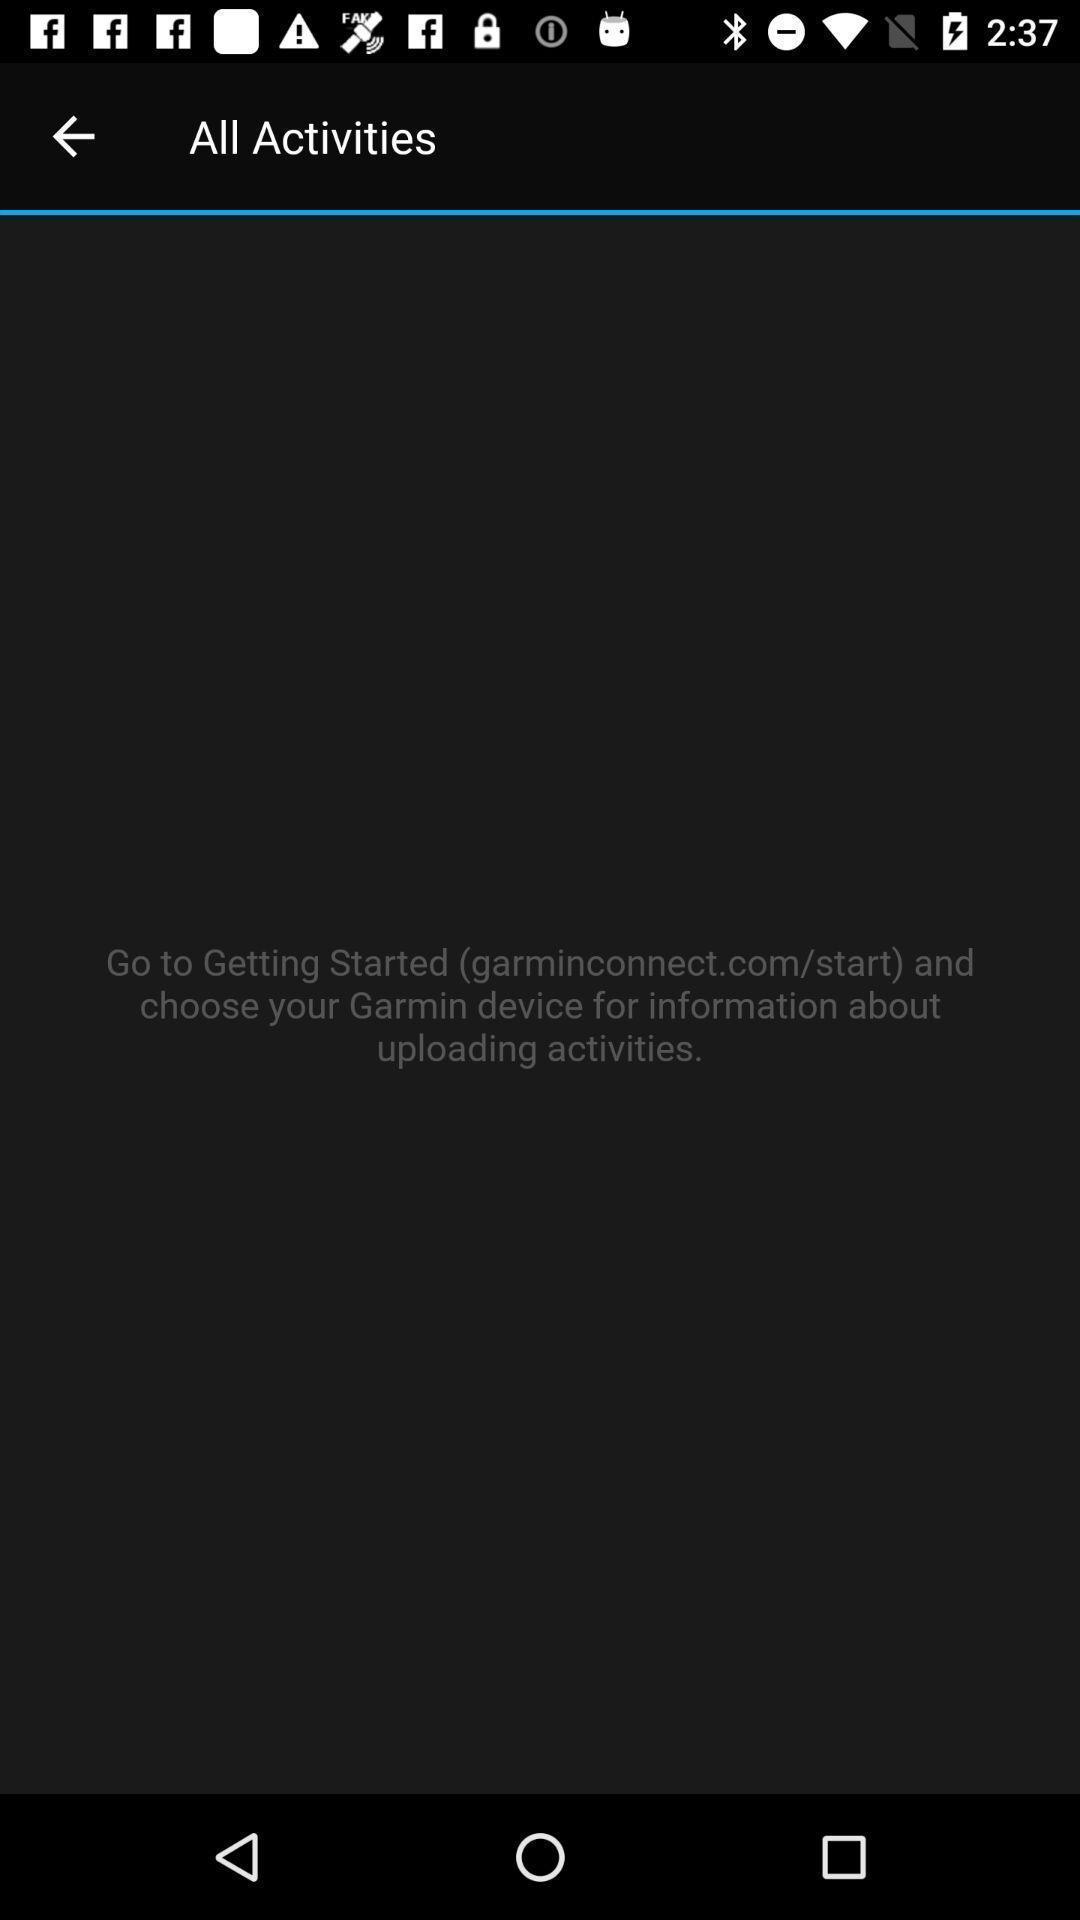Give me a narrative description of this picture. Screen displays all activities. 